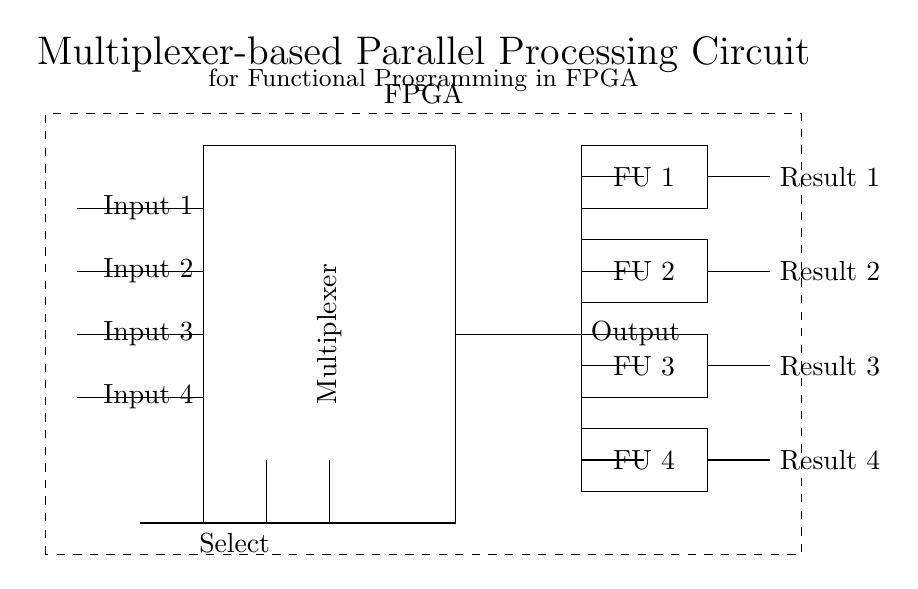What is the role of the multiplexer in this circuit? The multiplexer selects one of the multiple input signals based on the select lines and forwards it to the output. It facilitates parallel processing by allowing only one input to pass through at a time while directing the selected input to the output.
Answer: selects input How many functional units are present in the circuit? There are four functional units denoted in the circuit diagram, labeled FU 1, FU 2, FU 3, and FU 4. They process the signal passed from the multiplexer simultaneously.
Answer: four What do the select lines control? The select lines determine which input signal from the multiplexer is directed to the output. The selection occurs based on the value or combination of the select lines.
Answer: input selection Which component receives the output from the multiplexer? The functional units (FU 1, FU 2, FU 3, FU 4) receive the output from the multiplexer. They each perform their functions on the selected output from the multiplexer.
Answer: functional units What type of circuit is shown in the diagram? The circuit is a multiplexer-based parallel processing circuit designed for implementation in FPGA. It allows for multiple input signals to be processed in parallel by different functional units.
Answer: multiplexer-based circuit 